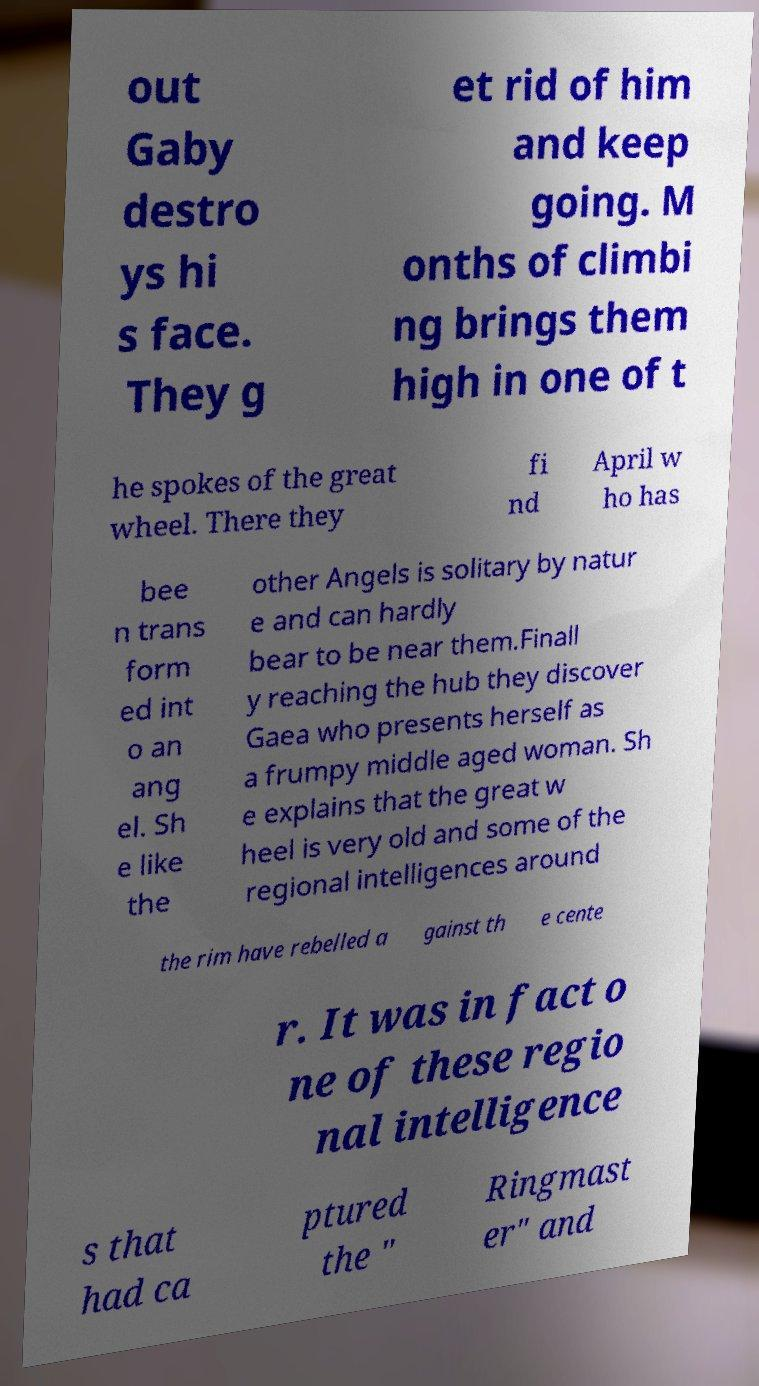Please read and relay the text visible in this image. What does it say? out Gaby destro ys hi s face. They g et rid of him and keep going. M onths of climbi ng brings them high in one of t he spokes of the great wheel. There they fi nd April w ho has bee n trans form ed int o an ang el. Sh e like the other Angels is solitary by natur e and can hardly bear to be near them.Finall y reaching the hub they discover Gaea who presents herself as a frumpy middle aged woman. Sh e explains that the great w heel is very old and some of the regional intelligences around the rim have rebelled a gainst th e cente r. It was in fact o ne of these regio nal intelligence s that had ca ptured the " Ringmast er" and 